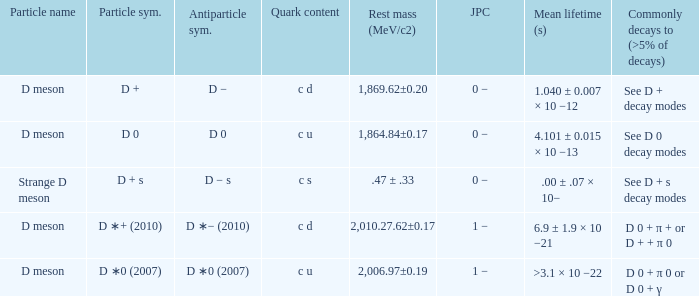What is the j p c that commonly decays (>5% of decays) d 0 + π 0 or d 0 + γ? 1 −. 